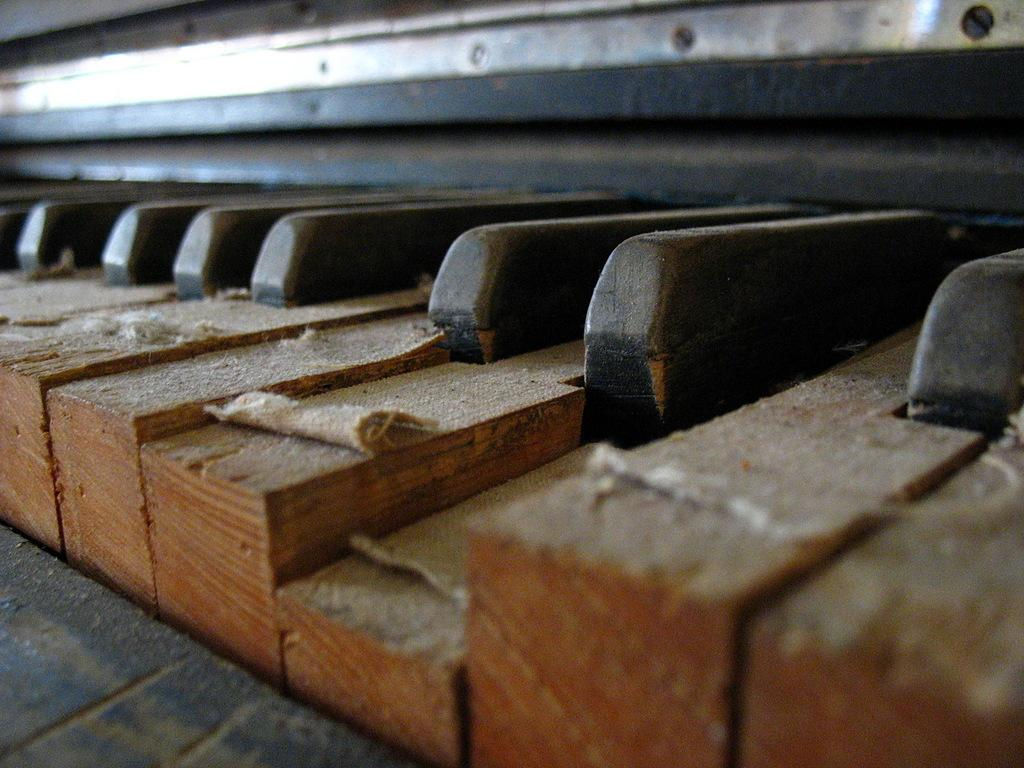What type of instrument is in the image? There is a wooden piano in the image. What feature of the piano is visible in the image? The piano has keys. How many pizzas are placed on top of the piano in the image? There are no pizzas present in the image; it features a wooden piano with keys. What type of cloth is draped over the piano in the image? There is no cloth draped over the piano in the image; it is a wooden piano with keys. 